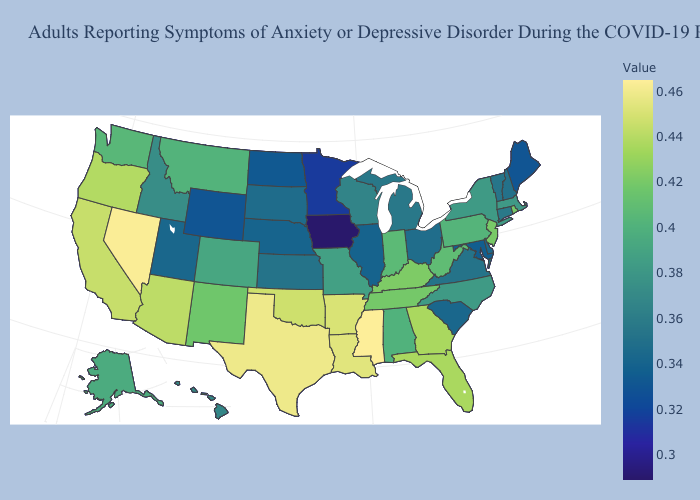Which states have the lowest value in the MidWest?
Short answer required. Iowa. Does the map have missing data?
Give a very brief answer. No. Which states have the highest value in the USA?
Answer briefly. Mississippi. Among the states that border Wisconsin , does Minnesota have the highest value?
Write a very short answer. No. 